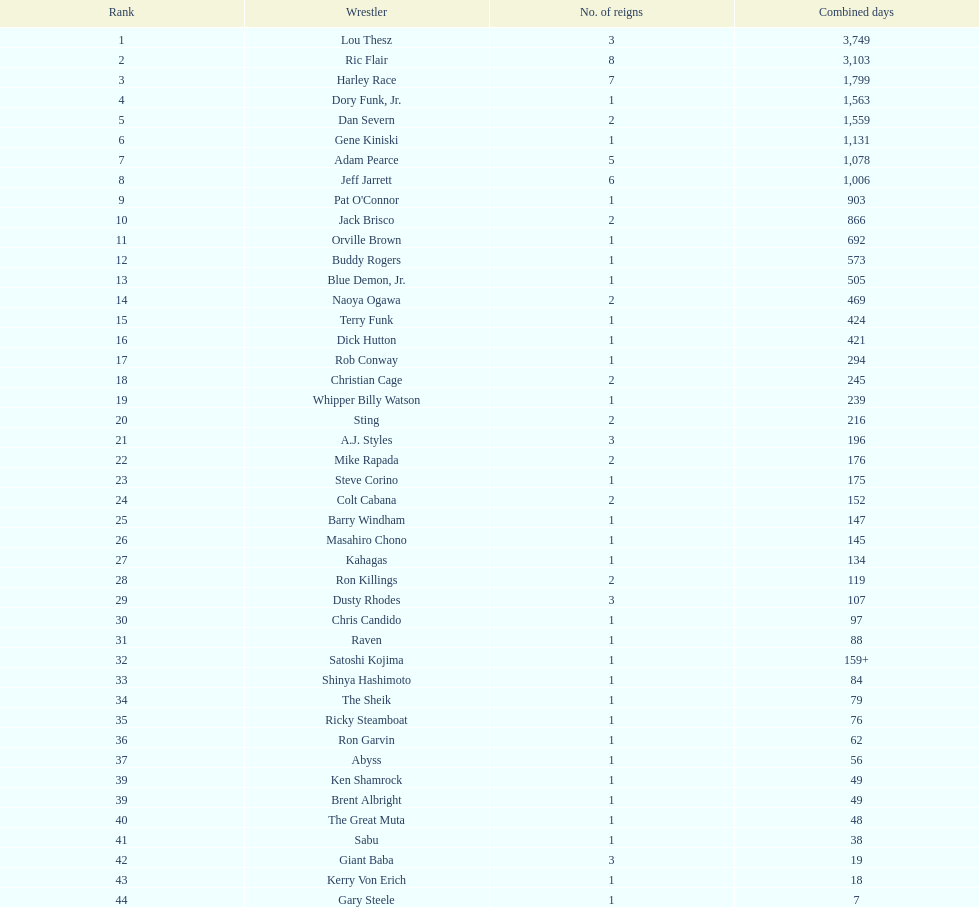Which professional wrestler has claimed the nwa world heavyweight championship title more times than any other? Ric Flair. 